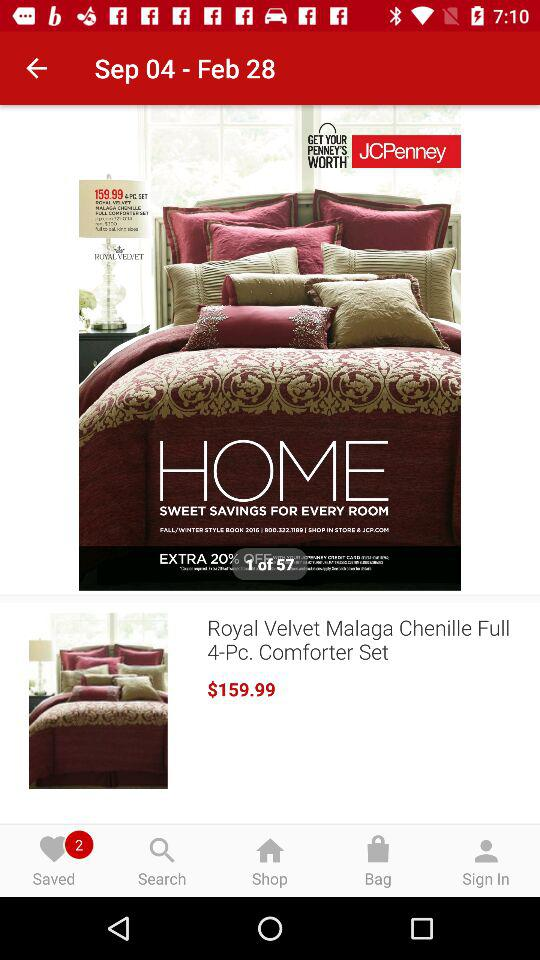What's the price of the "Royal Velvet Malaga Chenille"? The price of the "Royal Velvet Malaga Chenille" is $159.99. 